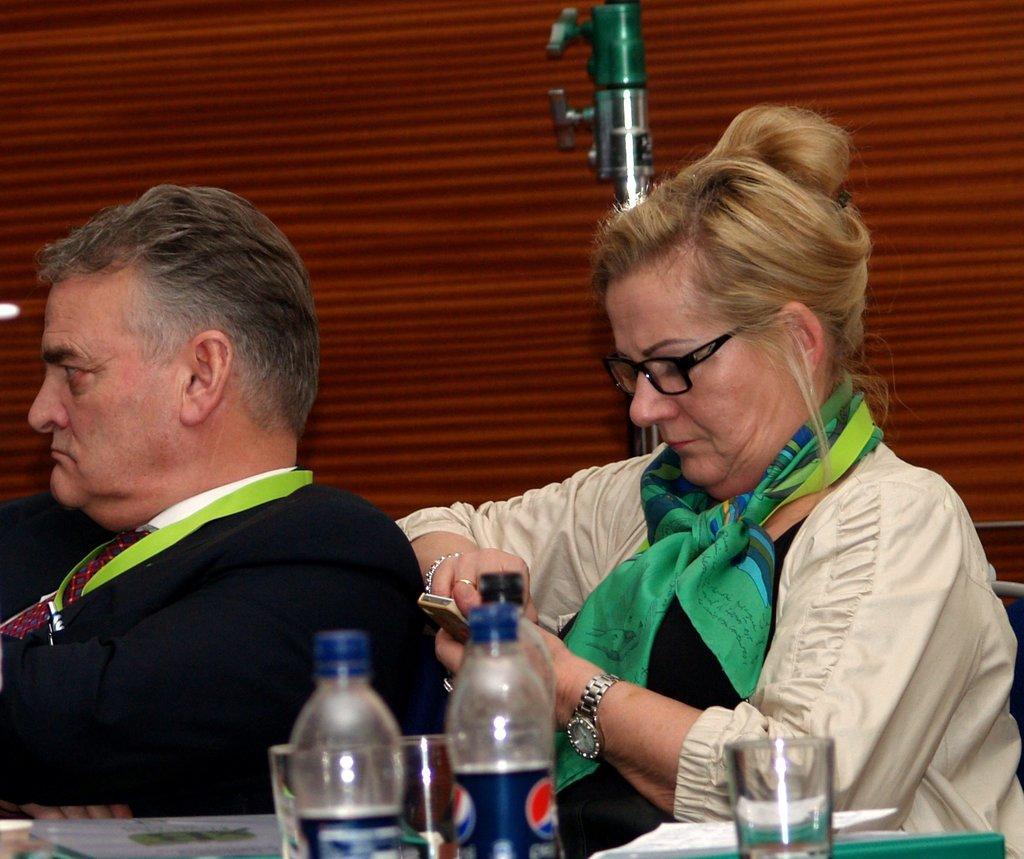Describe this image in one or two sentences. there is a man and woman sitting behind them there is a table and some bottles with glasses in it. 